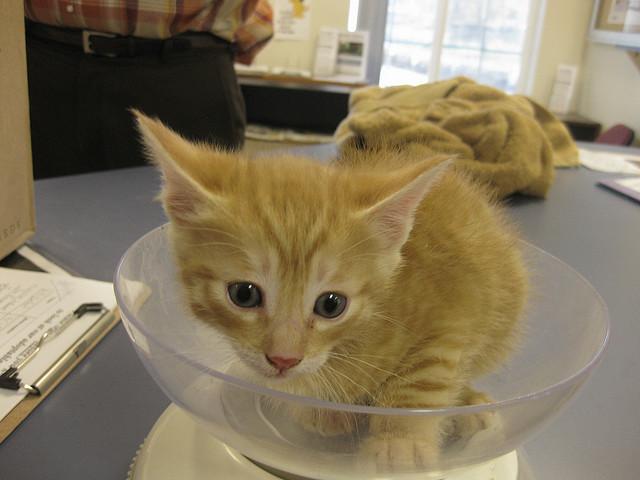Is the cat on an expensive plate?
Give a very brief answer. No. Is this a kitten?
Answer briefly. Yes. Is this an adult cat?
Answer briefly. No. What is the object to the left of the cat?
Keep it brief. Clipboard. Is the cat relaxed?
Concise answer only. No. Is the cat tired?
Quick response, please. No. What color are the cat's eyes?
Give a very brief answer. Gray. 